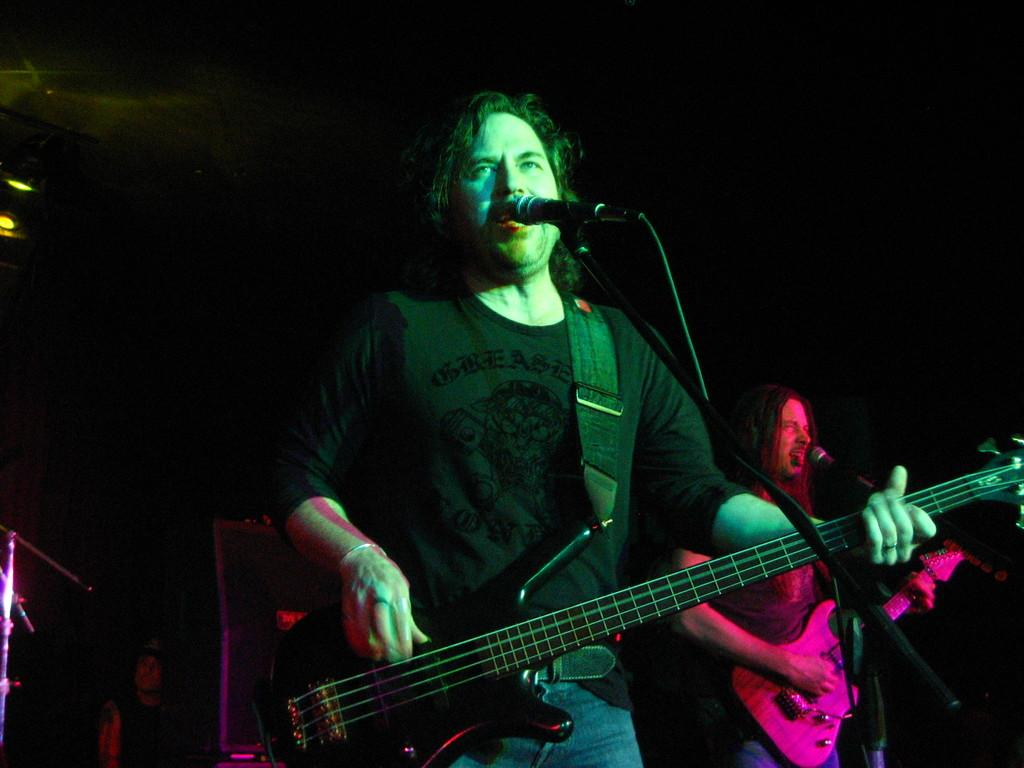How many people are in the image? There are two persons in the image. What are the persons holding in the image? The persons are holding guitars. What are the persons doing with the guitars? The persons are playing the guitars. How are the persons communicating their music in the image? The persons are singing through a microphone. What is the color of the background in the image? The background of the image is dark. What type of appliance is being used to celebrate the birthday in the image? There is no appliance or birthday celebration present in the image; it features two persons playing guitars and singing through a microphone. What type of magic trick is being performed by the persons in the image? There is no magic trick being performed in the image; the persons are playing guitars and singing through a microphone. 